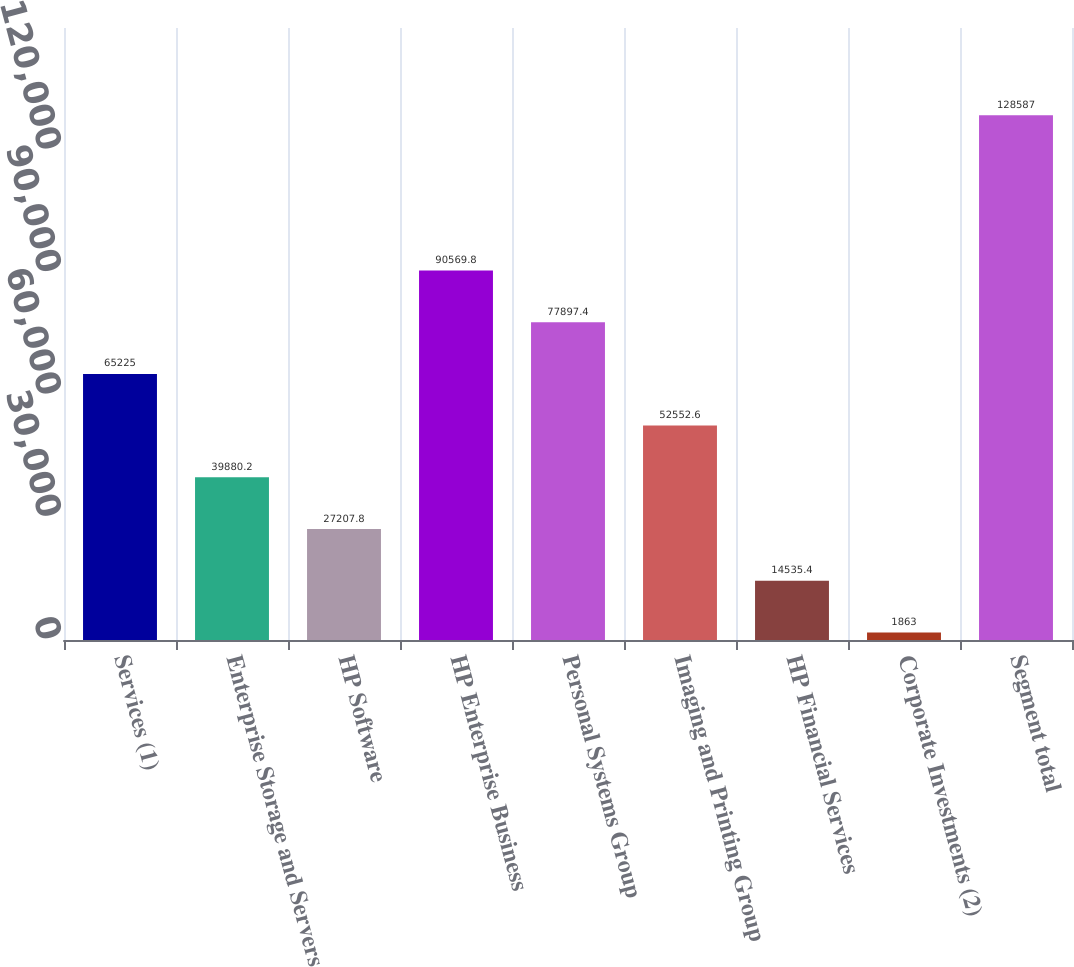Convert chart to OTSL. <chart><loc_0><loc_0><loc_500><loc_500><bar_chart><fcel>Services (1)<fcel>Enterprise Storage and Servers<fcel>HP Software<fcel>HP Enterprise Business<fcel>Personal Systems Group<fcel>Imaging and Printing Group<fcel>HP Financial Services<fcel>Corporate Investments (2)<fcel>Segment total<nl><fcel>65225<fcel>39880.2<fcel>27207.8<fcel>90569.8<fcel>77897.4<fcel>52552.6<fcel>14535.4<fcel>1863<fcel>128587<nl></chart> 